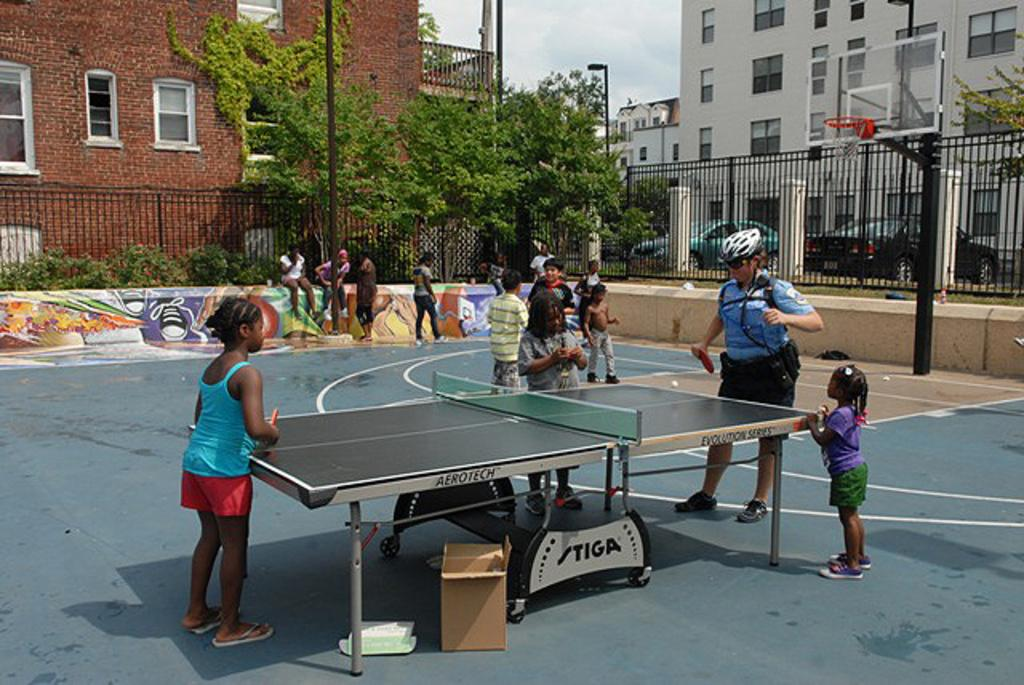How many people are in the image? There is a group of people in the image. What are two people in the group doing? Two people are playing table tennis. What can be seen in the background of the image? There are buildings, cars, poles, and trees visible in the background of the image. What type of record can be seen being played on a turntable in the image? There is no turntable or record present in the image; it features a group of people playing table tennis and a background with buildings, cars, poles, and trees. 